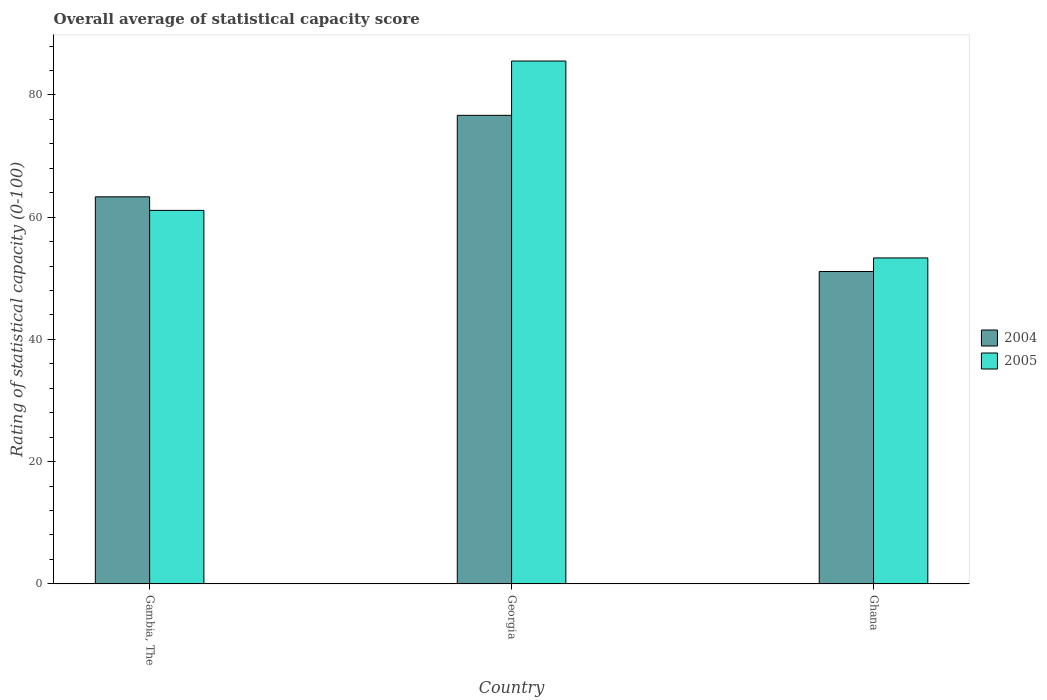How many different coloured bars are there?
Make the answer very short. 2. How many groups of bars are there?
Ensure brevity in your answer.  3. Are the number of bars per tick equal to the number of legend labels?
Offer a very short reply. Yes. How many bars are there on the 3rd tick from the right?
Keep it short and to the point. 2. What is the label of the 1st group of bars from the left?
Offer a very short reply. Gambia, The. In how many cases, is the number of bars for a given country not equal to the number of legend labels?
Your answer should be very brief. 0. What is the rating of statistical capacity in 2005 in Gambia, The?
Provide a succinct answer. 61.11. Across all countries, what is the maximum rating of statistical capacity in 2004?
Give a very brief answer. 76.67. Across all countries, what is the minimum rating of statistical capacity in 2004?
Offer a very short reply. 51.11. In which country was the rating of statistical capacity in 2004 maximum?
Offer a very short reply. Georgia. In which country was the rating of statistical capacity in 2004 minimum?
Make the answer very short. Ghana. What is the total rating of statistical capacity in 2005 in the graph?
Provide a succinct answer. 200. What is the difference between the rating of statistical capacity in 2005 in Gambia, The and that in Ghana?
Offer a very short reply. 7.78. What is the difference between the rating of statistical capacity in 2004 in Ghana and the rating of statistical capacity in 2005 in Gambia, The?
Provide a short and direct response. -10. What is the average rating of statistical capacity in 2005 per country?
Give a very brief answer. 66.67. What is the difference between the rating of statistical capacity of/in 2004 and rating of statistical capacity of/in 2005 in Ghana?
Offer a very short reply. -2.22. What is the ratio of the rating of statistical capacity in 2005 in Gambia, The to that in Ghana?
Provide a succinct answer. 1.15. Is the rating of statistical capacity in 2005 in Gambia, The less than that in Ghana?
Offer a terse response. No. What is the difference between the highest and the second highest rating of statistical capacity in 2004?
Offer a very short reply. -25.56. What is the difference between the highest and the lowest rating of statistical capacity in 2004?
Offer a terse response. 25.56. What does the 2nd bar from the right in Ghana represents?
Your answer should be very brief. 2004. Are all the bars in the graph horizontal?
Offer a terse response. No. What is the difference between two consecutive major ticks on the Y-axis?
Provide a short and direct response. 20. Are the values on the major ticks of Y-axis written in scientific E-notation?
Offer a terse response. No. Does the graph contain any zero values?
Provide a succinct answer. No. Where does the legend appear in the graph?
Your answer should be very brief. Center right. How many legend labels are there?
Offer a terse response. 2. How are the legend labels stacked?
Offer a terse response. Vertical. What is the title of the graph?
Ensure brevity in your answer.  Overall average of statistical capacity score. Does "2004" appear as one of the legend labels in the graph?
Offer a terse response. Yes. What is the label or title of the X-axis?
Your answer should be very brief. Country. What is the label or title of the Y-axis?
Provide a short and direct response. Rating of statistical capacity (0-100). What is the Rating of statistical capacity (0-100) of 2004 in Gambia, The?
Provide a succinct answer. 63.33. What is the Rating of statistical capacity (0-100) in 2005 in Gambia, The?
Offer a terse response. 61.11. What is the Rating of statistical capacity (0-100) of 2004 in Georgia?
Ensure brevity in your answer.  76.67. What is the Rating of statistical capacity (0-100) in 2005 in Georgia?
Your answer should be compact. 85.56. What is the Rating of statistical capacity (0-100) of 2004 in Ghana?
Ensure brevity in your answer.  51.11. What is the Rating of statistical capacity (0-100) in 2005 in Ghana?
Ensure brevity in your answer.  53.33. Across all countries, what is the maximum Rating of statistical capacity (0-100) in 2004?
Your answer should be compact. 76.67. Across all countries, what is the maximum Rating of statistical capacity (0-100) in 2005?
Provide a short and direct response. 85.56. Across all countries, what is the minimum Rating of statistical capacity (0-100) in 2004?
Offer a terse response. 51.11. Across all countries, what is the minimum Rating of statistical capacity (0-100) of 2005?
Offer a terse response. 53.33. What is the total Rating of statistical capacity (0-100) in 2004 in the graph?
Provide a short and direct response. 191.11. What is the difference between the Rating of statistical capacity (0-100) of 2004 in Gambia, The and that in Georgia?
Make the answer very short. -13.33. What is the difference between the Rating of statistical capacity (0-100) of 2005 in Gambia, The and that in Georgia?
Offer a very short reply. -24.44. What is the difference between the Rating of statistical capacity (0-100) of 2004 in Gambia, The and that in Ghana?
Provide a short and direct response. 12.22. What is the difference between the Rating of statistical capacity (0-100) of 2005 in Gambia, The and that in Ghana?
Ensure brevity in your answer.  7.78. What is the difference between the Rating of statistical capacity (0-100) in 2004 in Georgia and that in Ghana?
Offer a very short reply. 25.56. What is the difference between the Rating of statistical capacity (0-100) in 2005 in Georgia and that in Ghana?
Offer a very short reply. 32.22. What is the difference between the Rating of statistical capacity (0-100) of 2004 in Gambia, The and the Rating of statistical capacity (0-100) of 2005 in Georgia?
Your answer should be compact. -22.22. What is the difference between the Rating of statistical capacity (0-100) in 2004 in Georgia and the Rating of statistical capacity (0-100) in 2005 in Ghana?
Keep it short and to the point. 23.33. What is the average Rating of statistical capacity (0-100) in 2004 per country?
Your response must be concise. 63.7. What is the average Rating of statistical capacity (0-100) of 2005 per country?
Offer a terse response. 66.67. What is the difference between the Rating of statistical capacity (0-100) of 2004 and Rating of statistical capacity (0-100) of 2005 in Gambia, The?
Offer a very short reply. 2.22. What is the difference between the Rating of statistical capacity (0-100) in 2004 and Rating of statistical capacity (0-100) in 2005 in Georgia?
Make the answer very short. -8.89. What is the difference between the Rating of statistical capacity (0-100) of 2004 and Rating of statistical capacity (0-100) of 2005 in Ghana?
Your answer should be very brief. -2.22. What is the ratio of the Rating of statistical capacity (0-100) of 2004 in Gambia, The to that in Georgia?
Ensure brevity in your answer.  0.83. What is the ratio of the Rating of statistical capacity (0-100) in 2005 in Gambia, The to that in Georgia?
Your answer should be very brief. 0.71. What is the ratio of the Rating of statistical capacity (0-100) in 2004 in Gambia, The to that in Ghana?
Offer a terse response. 1.24. What is the ratio of the Rating of statistical capacity (0-100) of 2005 in Gambia, The to that in Ghana?
Give a very brief answer. 1.15. What is the ratio of the Rating of statistical capacity (0-100) in 2005 in Georgia to that in Ghana?
Your response must be concise. 1.6. What is the difference between the highest and the second highest Rating of statistical capacity (0-100) in 2004?
Offer a very short reply. 13.33. What is the difference between the highest and the second highest Rating of statistical capacity (0-100) of 2005?
Keep it short and to the point. 24.44. What is the difference between the highest and the lowest Rating of statistical capacity (0-100) in 2004?
Make the answer very short. 25.56. What is the difference between the highest and the lowest Rating of statistical capacity (0-100) of 2005?
Your answer should be very brief. 32.22. 